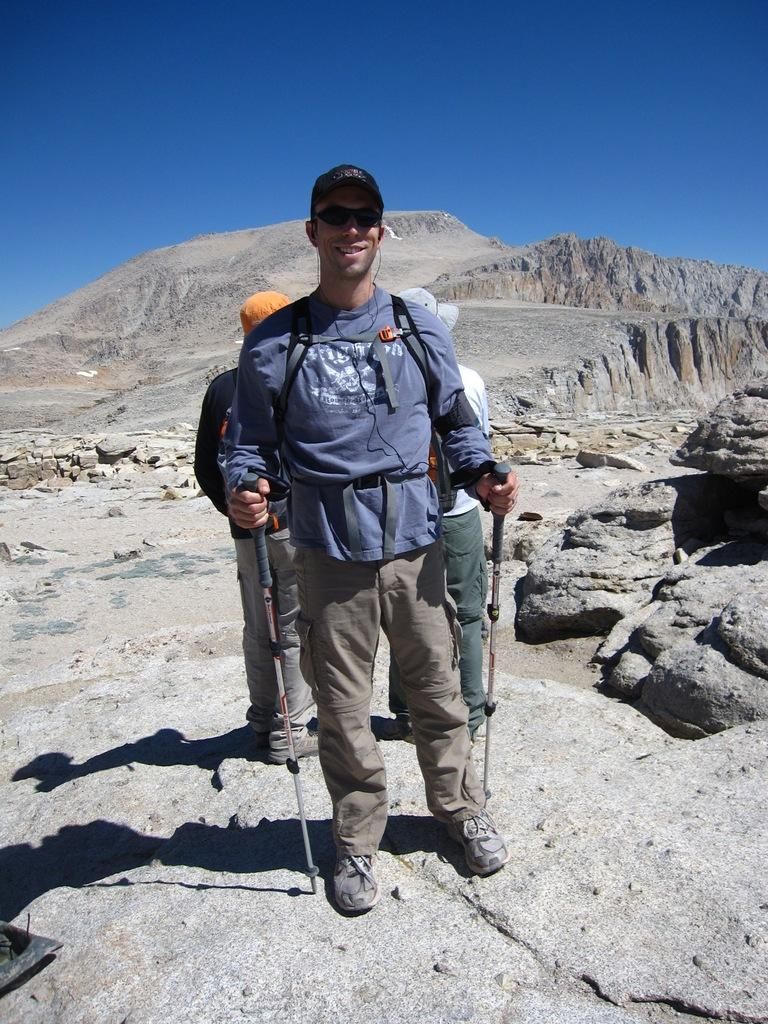What is the man in the image doing? The man is standing and smiling in the image. Where is the man located in relation to the mountains? The man is near the mountains in the image. Can you describe the background of the image? There is another person in the background of the image, and the sky is visible as well. What time does the man say good-bye to the mountains in the image? There is no indication in the image that the man is saying good-bye to the mountains, nor is there any information about the time. 